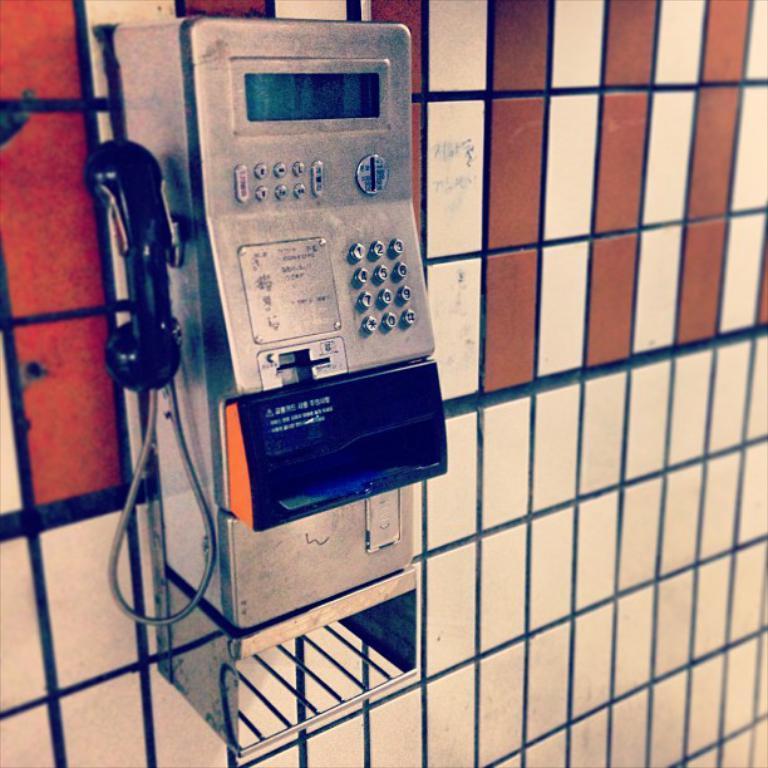Describe this image in one or two sentences. In this picture we can see a telephone on the wall. 